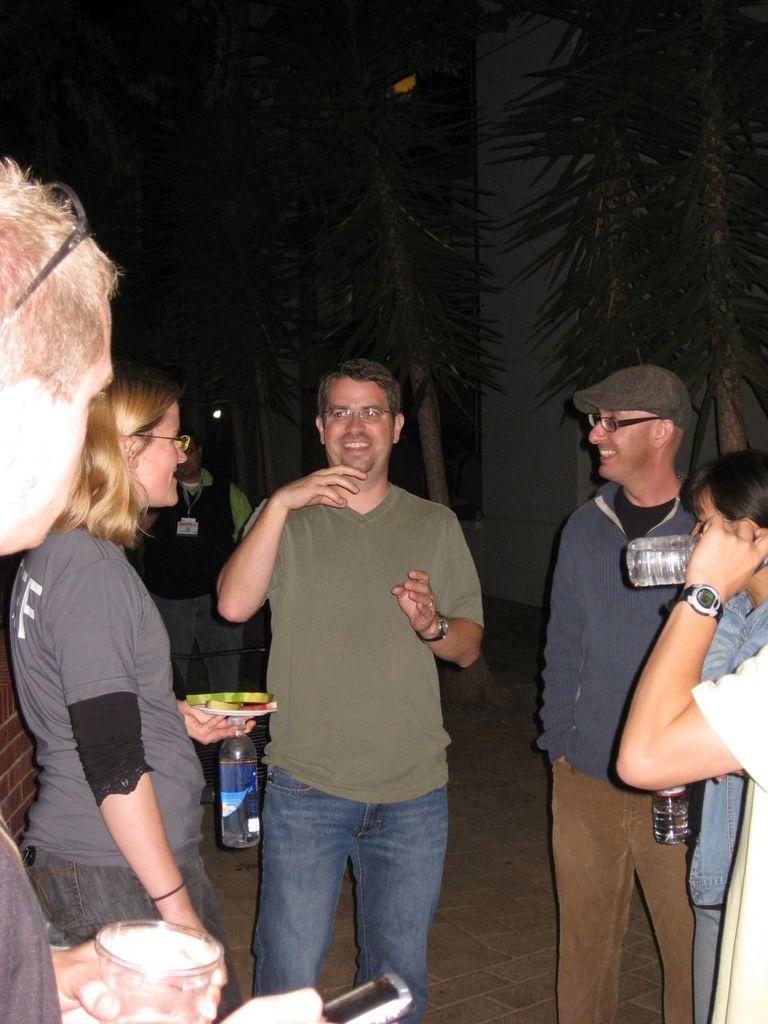How many people are in the image? There are people in the image, but the exact number is not specified. What are some of the people holding in the image? Some of the people are holding water bottles. What is one person holding that is not a water bottle? One person is holding a phone. What can be seen in the background of the image? There are trees visible in the background of the image. Can you see a snail crawling on the phone in the image? There is no snail present in the image, so it cannot be seen crawling on the phone. 